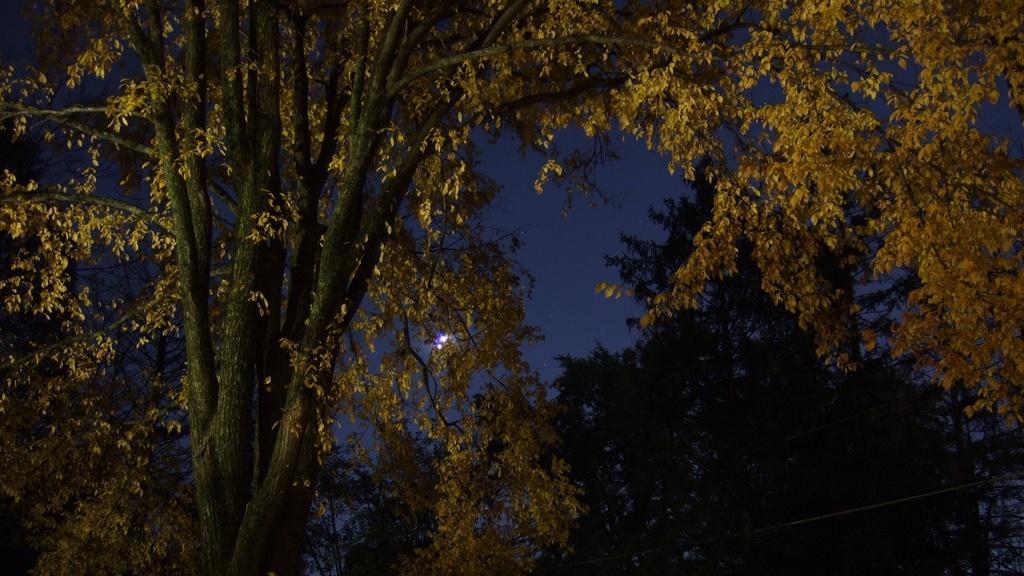Describe this image in one or two sentences. In this picture I can observe some trees. In the background there is a sky. 